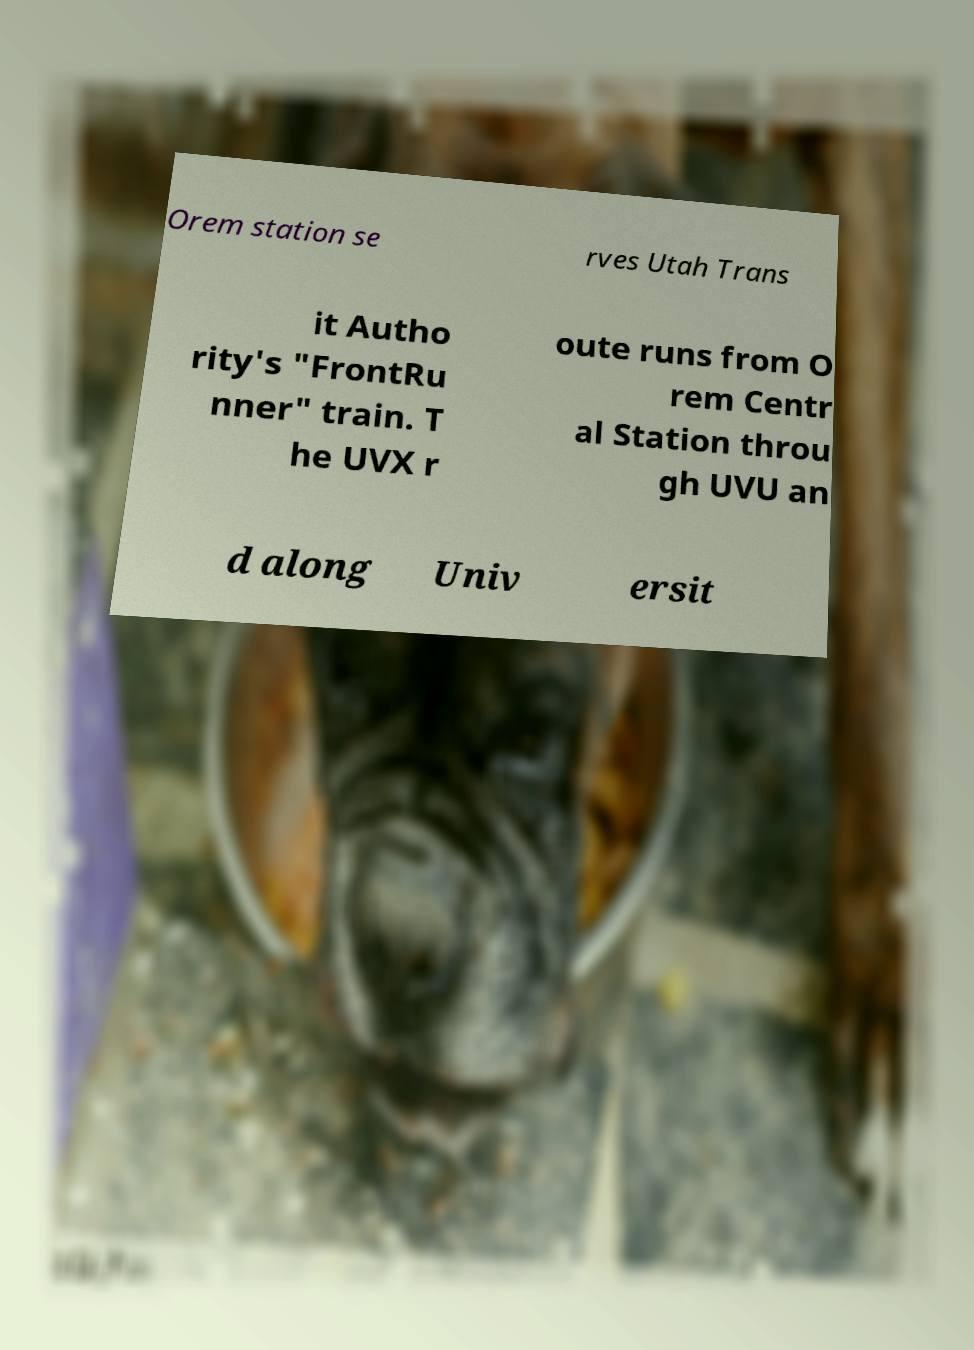Can you accurately transcribe the text from the provided image for me? Orem station se rves Utah Trans it Autho rity's "FrontRu nner" train. T he UVX r oute runs from O rem Centr al Station throu gh UVU an d along Univ ersit 